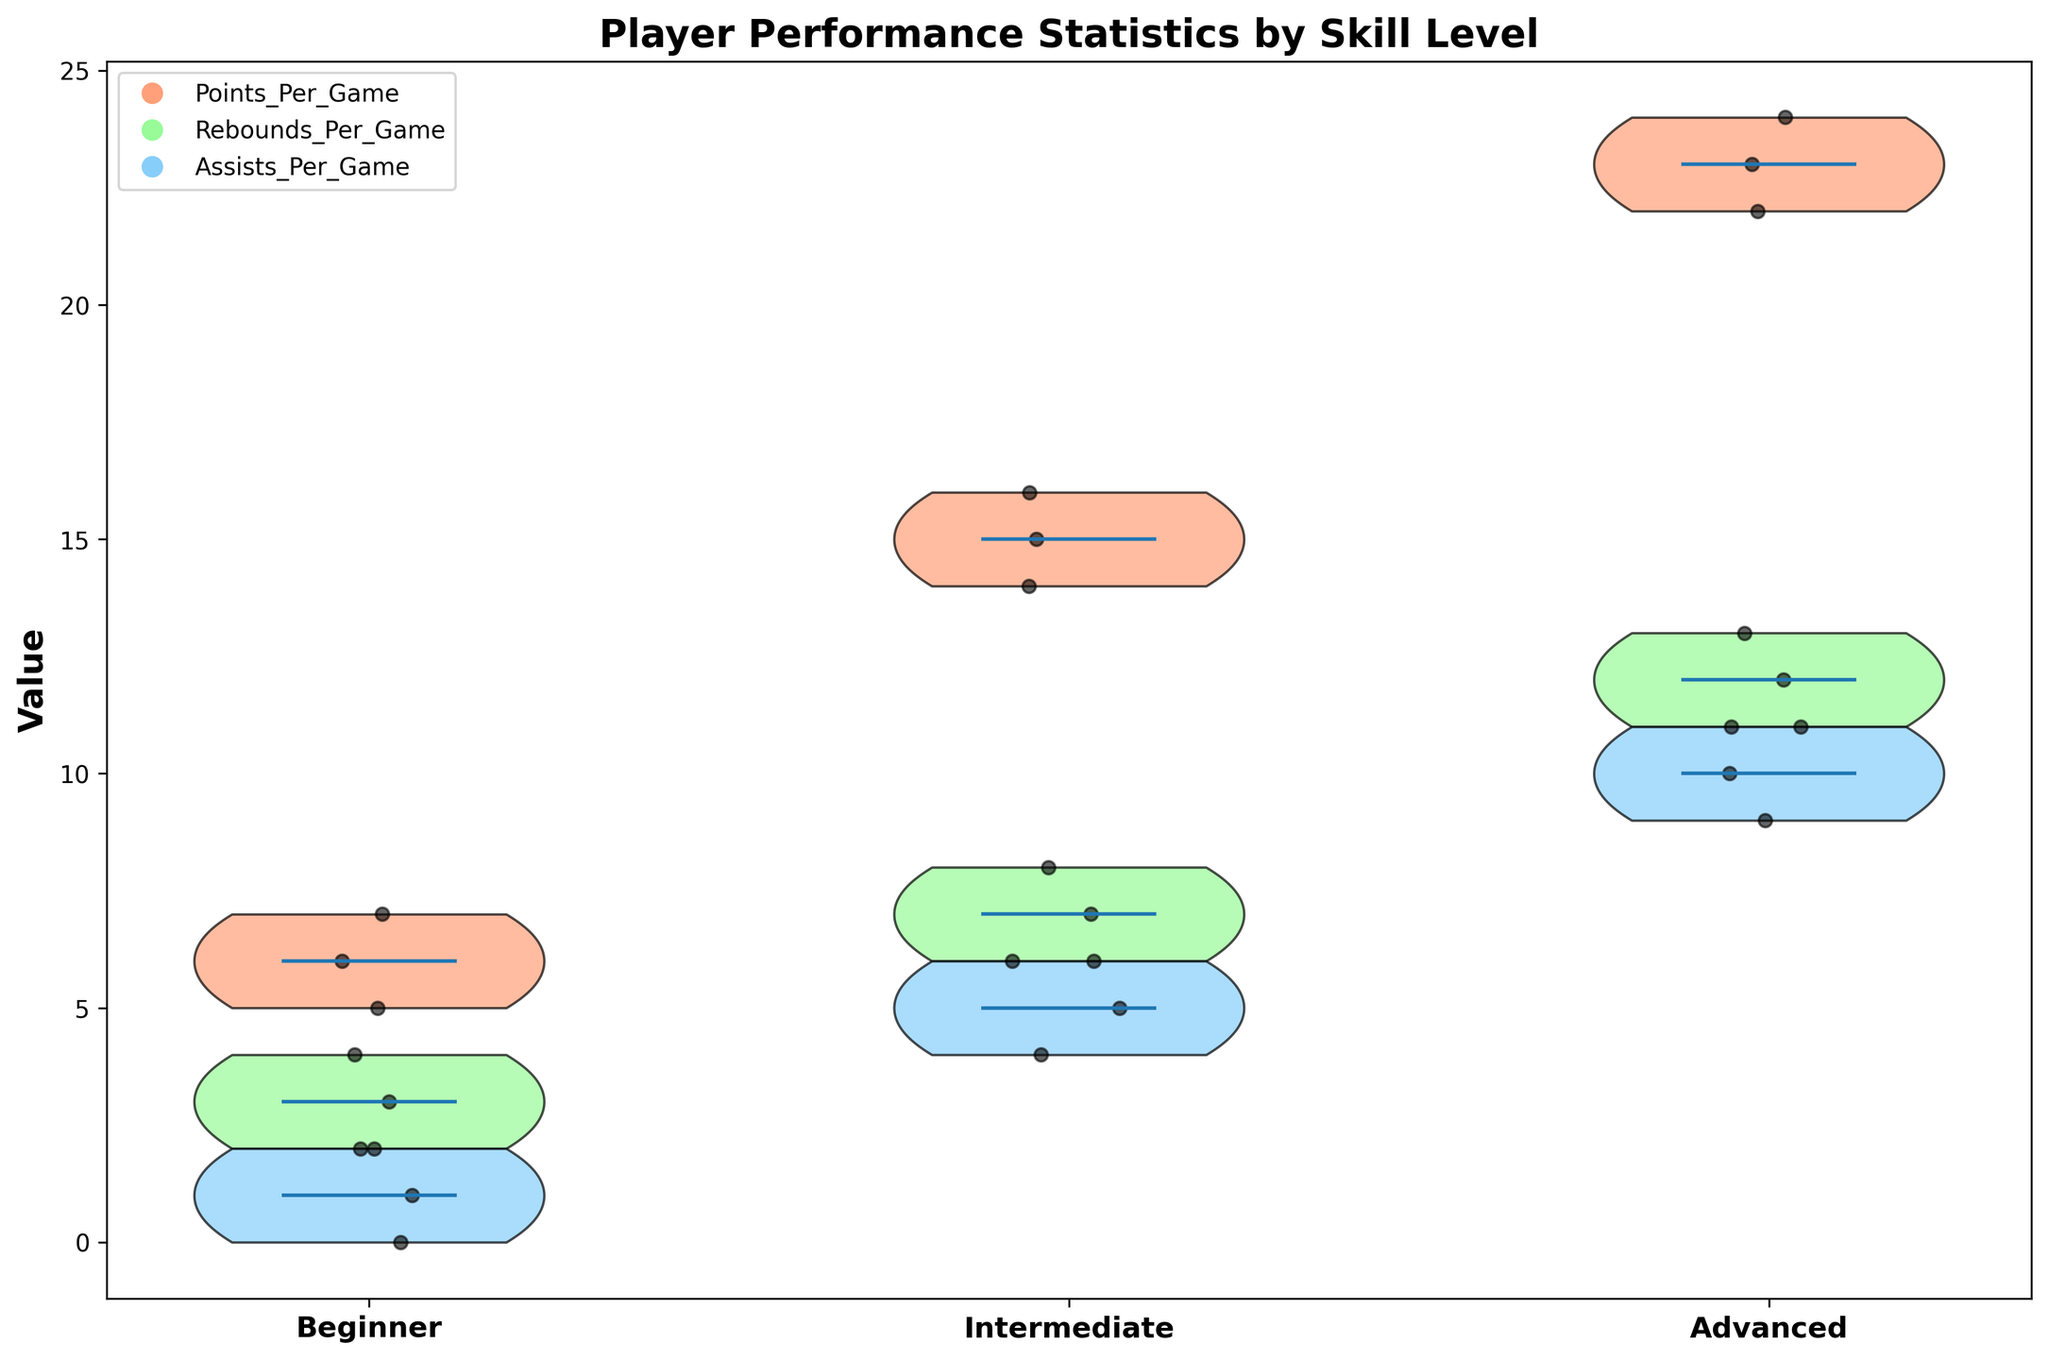what is the title of the chart? The title of the chart is displayed at the top of the figure and usually describes what the chart is about. In this case, it reads "Player Performance Statistics by Skill Level."
Answer: Player Performance Statistics by Skill Level How many skill levels are represented in the chart? The x-axis of the chart lists the skill levels, which are "Beginner," "Intermediate," and "Advanced."
Answer: Three What colors are used to represent the different performance metrics? The legend in the top left corner of the chart shows the color coding: red for Points Per Game, green for Rebounds Per Game, and blue for Assists Per Game.
Answer: Red, Green, Blue Which skill level has the highest median points per game? By observing the position of the median line within each violins corresponding to "Points Per Game," "Advanced" has the highest median.
Answer: Advanced How many data points are there for "Beginner" players in "Rebounds Per Game"? The scatter plot overlay within the "Beginner" section of the chart has 3 black dots for "Rebounds Per Game."
Answer: Three Which skill level shows the largest variability in "Assists Per Game"? The width and spread of the violin plot for "Assists Per Game" show that "Advanced" players have the largest variability.
Answer: Advanced What are the average points per game for "Intermediate" players? Sum the points per game for "Intermediate" players and divide by the number of data points: (15 + 14 + 16) / 3 = 45 / 3 = 15.
Answer: 15 Do "Advanced" players have more rebounds on average than "Beginner" players? Calculate the average rebounds for both: Beginners (2 + 3 + 4) / 3 = 3 and Advanced (12 + 11 + 13) / 3 = 12. "Advanced" has more.
Answer: Yes What is the range of assists per game for "Intermediate" players? Find the difference between the highest and lowest value for "Intermediate": Max = 6, Min = 4, Range = 6 - 4.
Answer: 2 Which skill level has the smallest median value in "Rebounds Per Game"? By checking the medians within the violin plots, "Beginner" has the smallest median for "Rebounds Per Game."
Answer: Beginner 